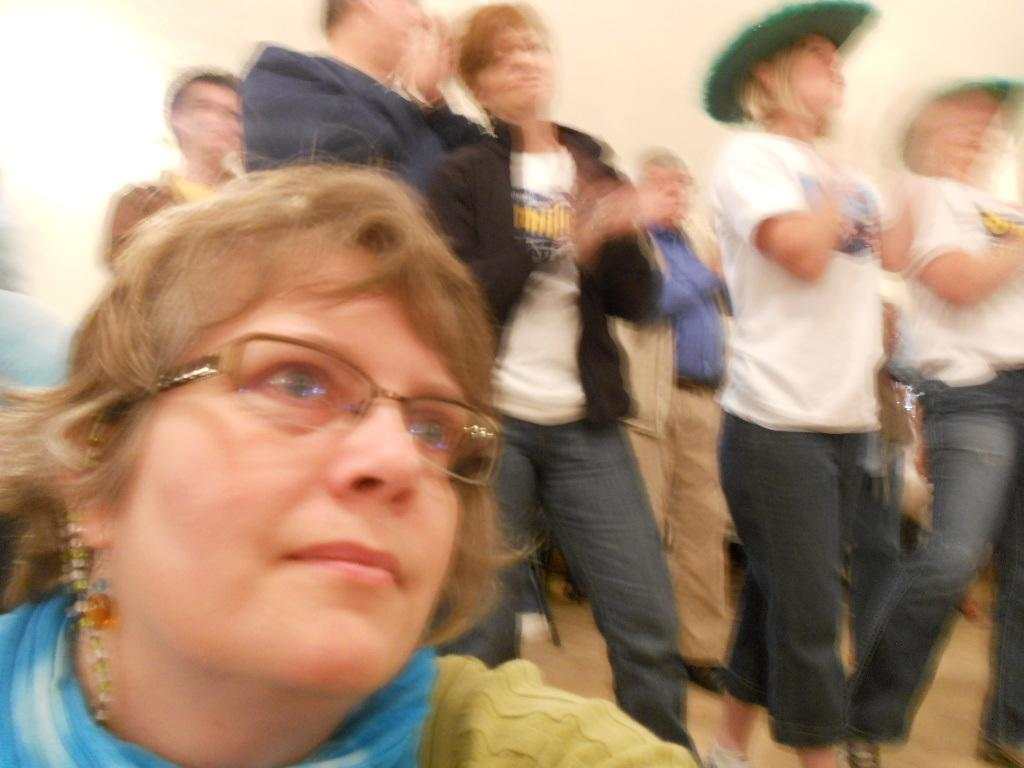How many people are in the image? There are a few people in the image. Can you describe the arrangement of the people in the image? The people are arranged from left to right. What type of club does the manager hold in the image? There is no manager or club present in the image. 